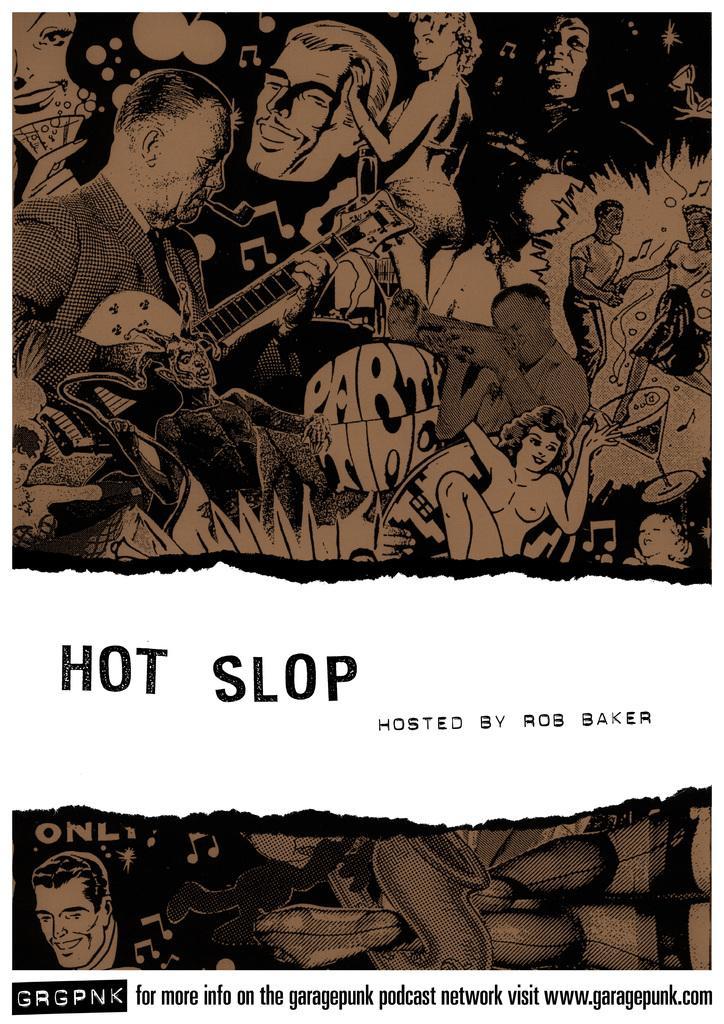Please provide a concise description of this image. This might be a poster, in this image there are group of people some of them are holding musical instruments, and there are some music symbols and there is text. 